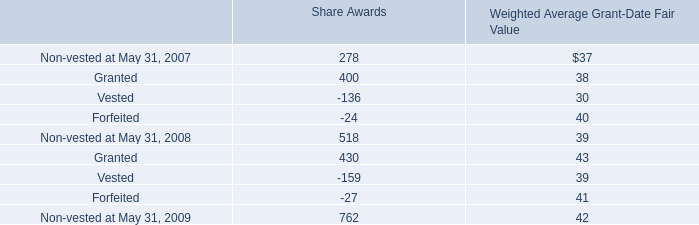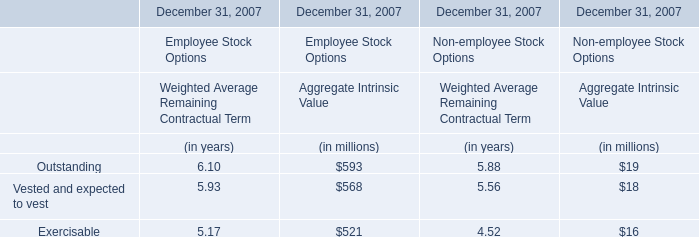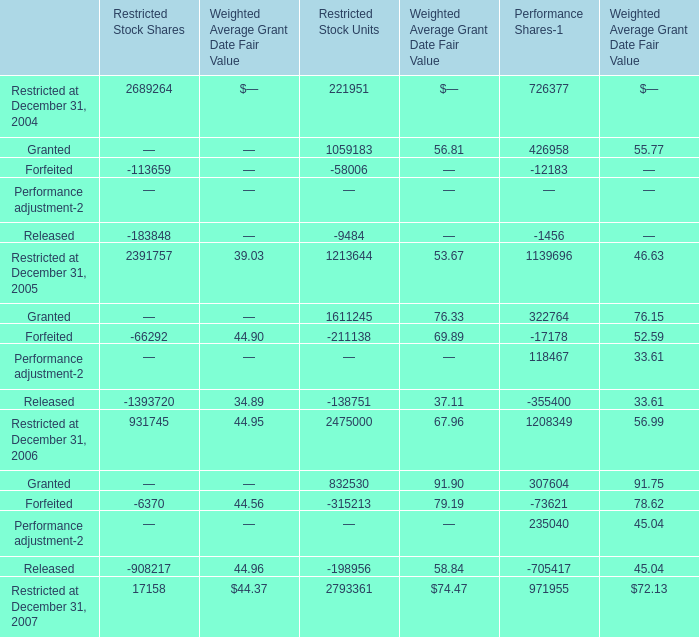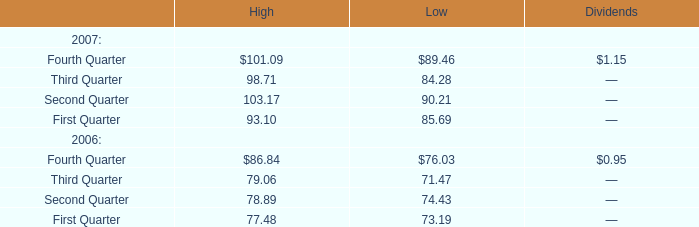In the year with largest amount of Restricted at December 31, 2005 what's the increasing rate of Forfeited ? 
Computations: ((-66292 - -6370) / -66292)
Answer: 0.90391. 